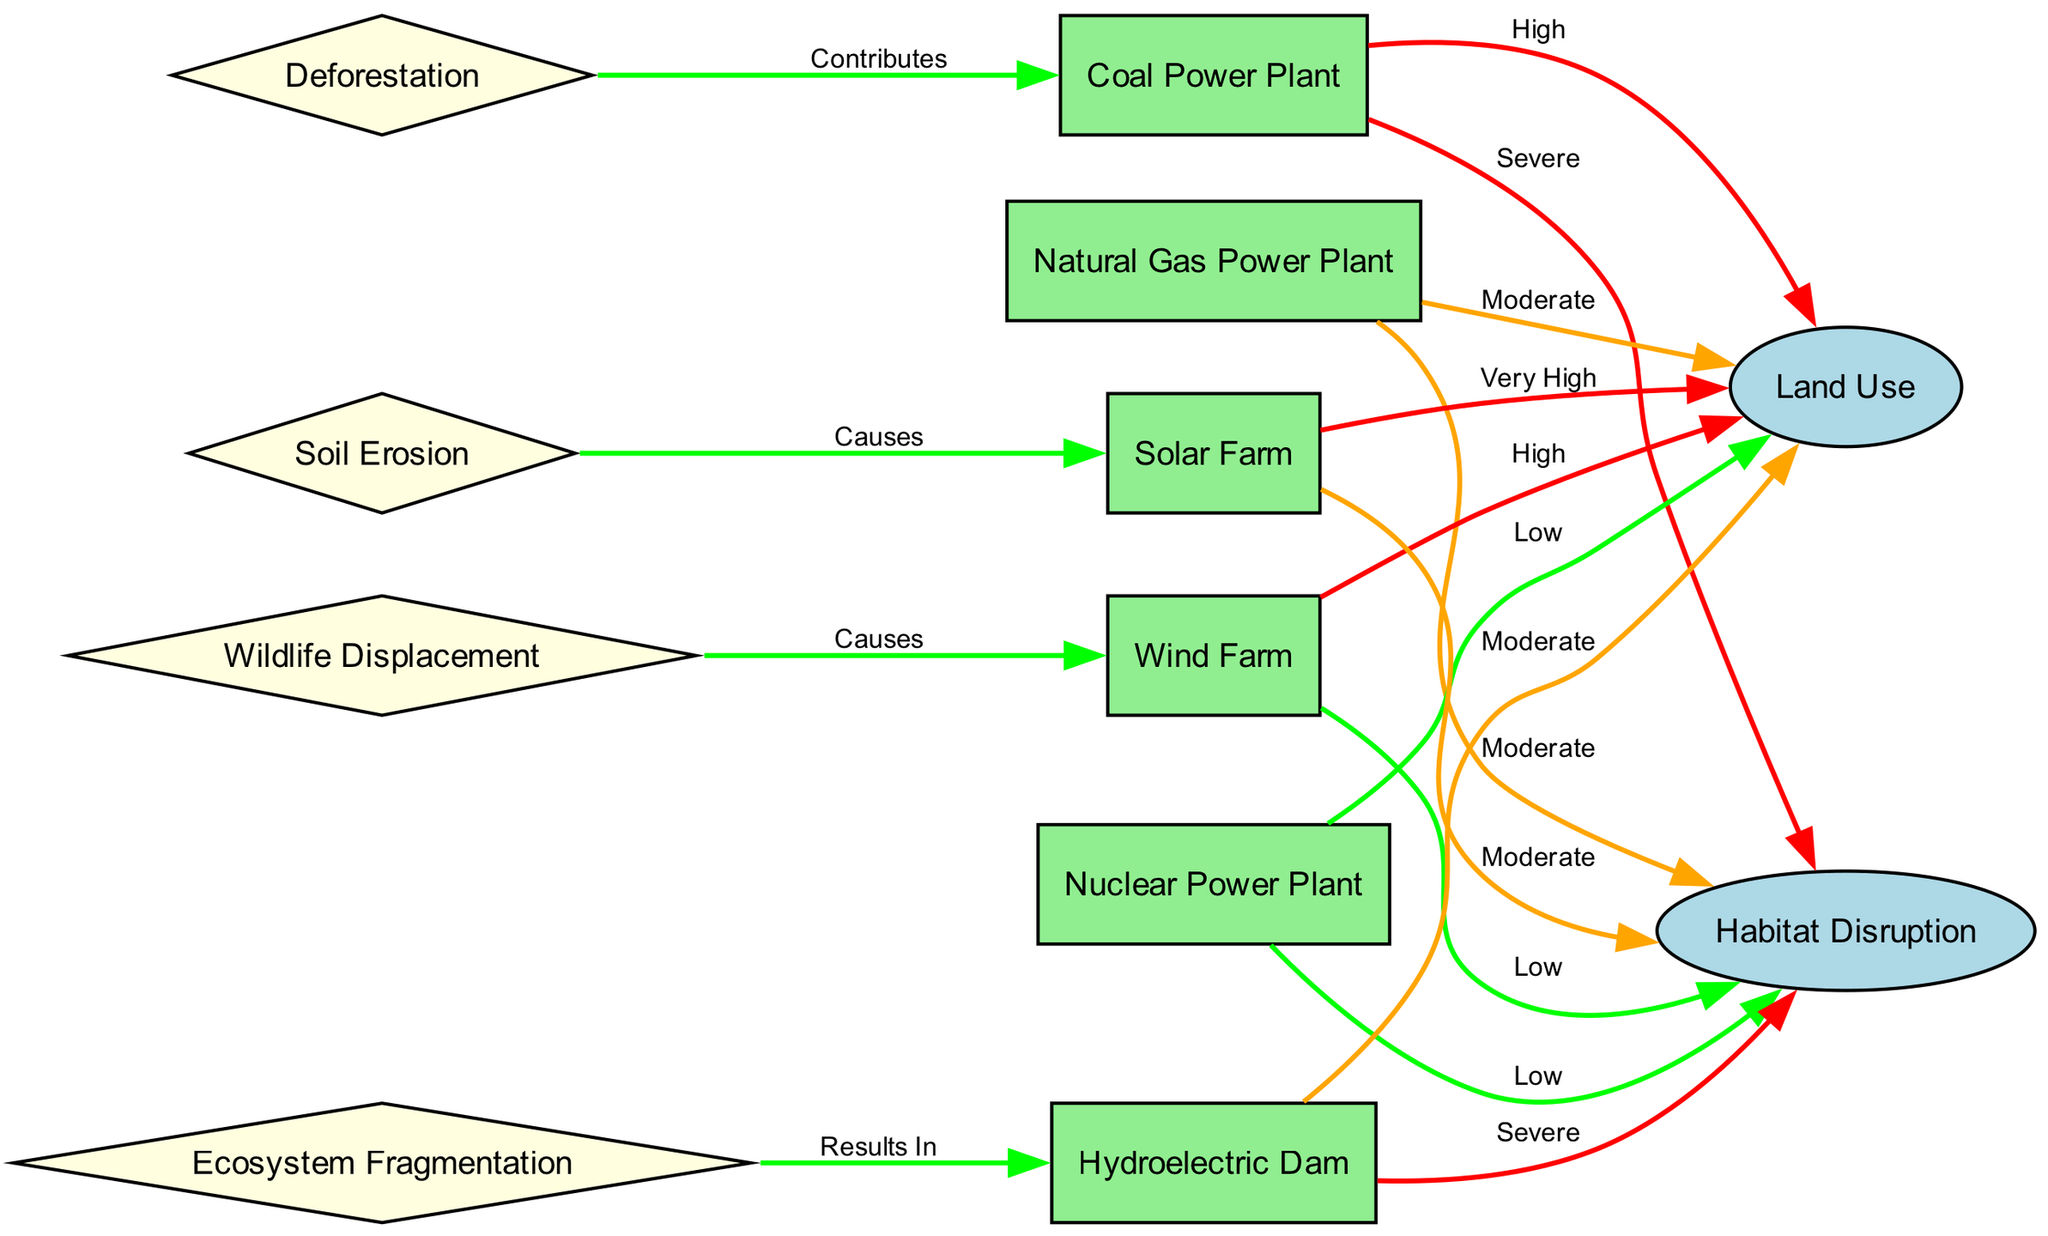What is the relationship between a coal power plant and land use? The diagram indicates that the coal power plant has a "High" impact on land use, as shown by the edge connecting the two nodes with a red label.
Answer: High Which power plant type has the lowest habitat disruption? The nuclear power plant is linked to the habitat disruption node with a "Low" label, indicating it has the least disruption among the options presented.
Answer: Low How many types of power plants are there in the diagram? There are six types of power plants depicted in the diagram: coal, natural gas, nuclear, wind, solar, and hydroelectric.
Answer: Six What type of power plant causes soil erosion? The diagram shows a direct relationship where "Soil Erosion" causes effects on the "Solar Farm," indicating that the solar farm is associated with soil erosion.
Answer: Solar Farm Which two aspects are directly linked to a hydroelectric dam? The hydroelectric dam is linked to both land use and habitat disruption; it has a "Moderate" impact on land use and a "Severe" impact on habitat disruption as indicated by the edges.
Answer: Land Use and Habitat Disruption Is wildlife displacement linked more to renewable or non-renewable energy sources? The diagram shows that wildlife displacement arises from the wind farm, which is a renewable energy source, but the connection is indicated as a cause, suggesting it’s an impact of renewable energy.
Answer: Renewable How does deforestation relate to coal power plants? The diagram indicates that deforestation contributes to coal power plants, showing that there is a contributory link where deforestation impacts the coal power plant's land use and habitat factors.
Answer: Contributes What is the impact level of a solar farm on land use? The solar farm is depicted as having a "Very High" impact on land use, indicated by the respective edge color and labeled connection.
Answer: Very High What consequence does ecosystem fragmentation have on hydroelectric dams? Ecosystem fragmentation results from the hydroelectric dam as indicated in the diagram, demonstrating a causal relationship where ecosystem fragmentation can be a result of the dam's construction and operation.
Answer: Results In 